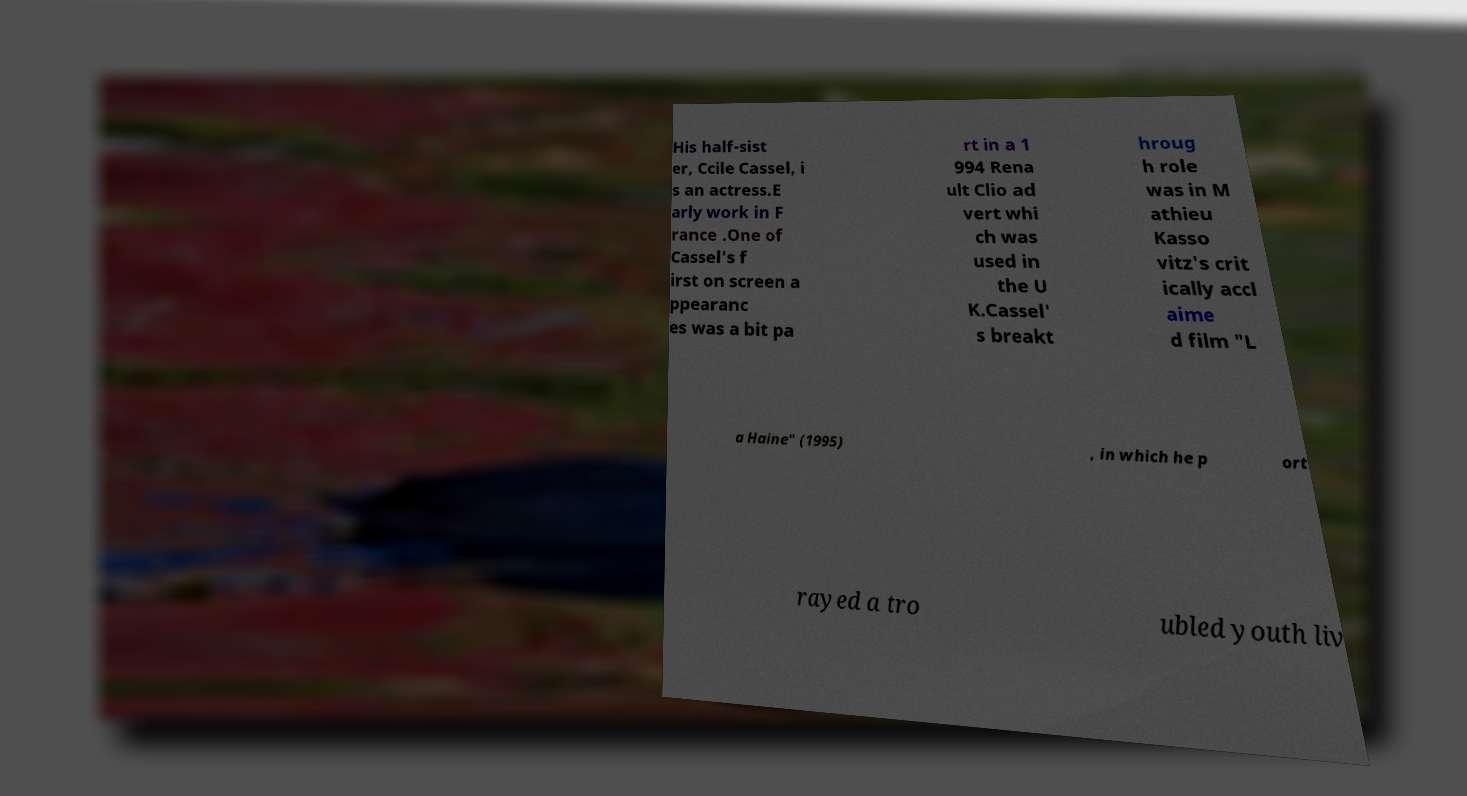What messages or text are displayed in this image? I need them in a readable, typed format. His half-sist er, Ccile Cassel, i s an actress.E arly work in F rance .One of Cassel's f irst on screen a ppearanc es was a bit pa rt in a 1 994 Rena ult Clio ad vert whi ch was used in the U K.Cassel' s breakt hroug h role was in M athieu Kasso vitz's crit ically accl aime d film "L a Haine" (1995) , in which he p ort rayed a tro ubled youth liv 